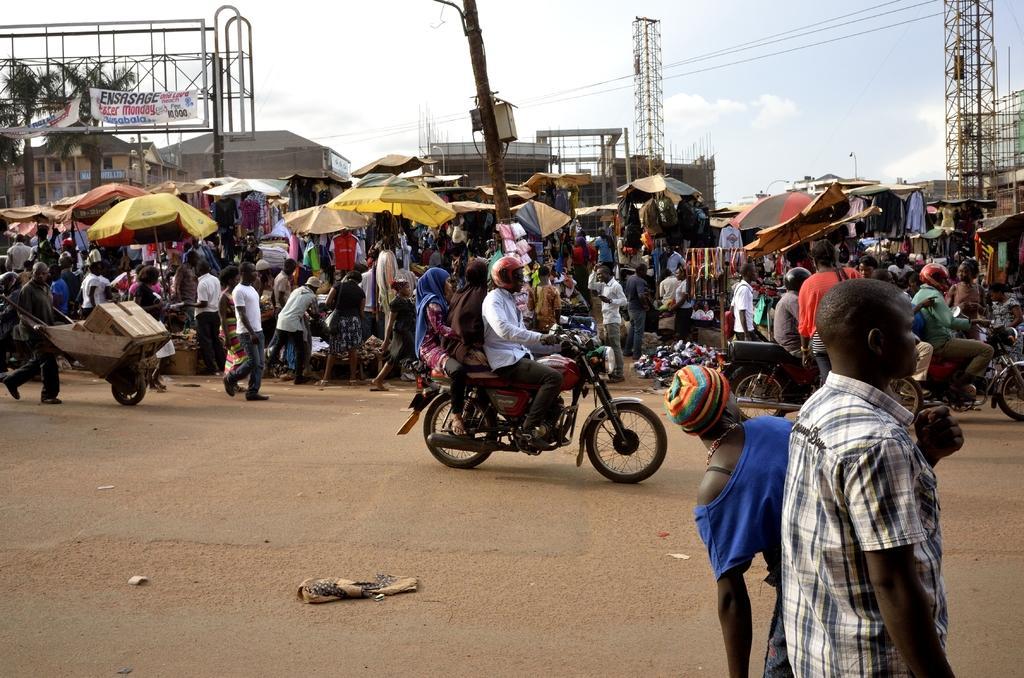Can you describe this image briefly? In this picture I can see group of people standing, there are vehicles on the road, there are stalls, umbrellas, there are clothes hanging to the umbrellas, there are banners, iron rods, buildings, poles, trees, and in the background there is sky. 